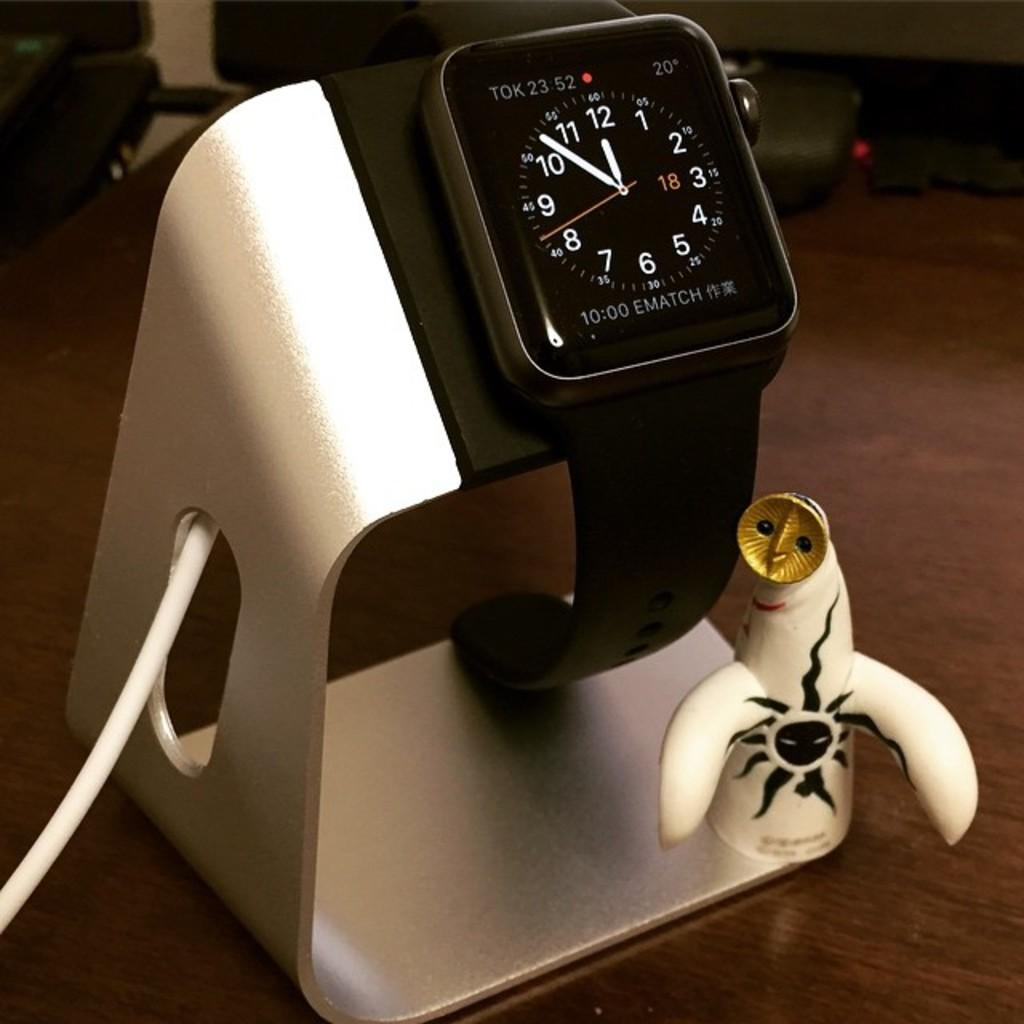<image>
Present a compact description of the photo's key features. An ematch watch is on display on a holder with a figurine. 